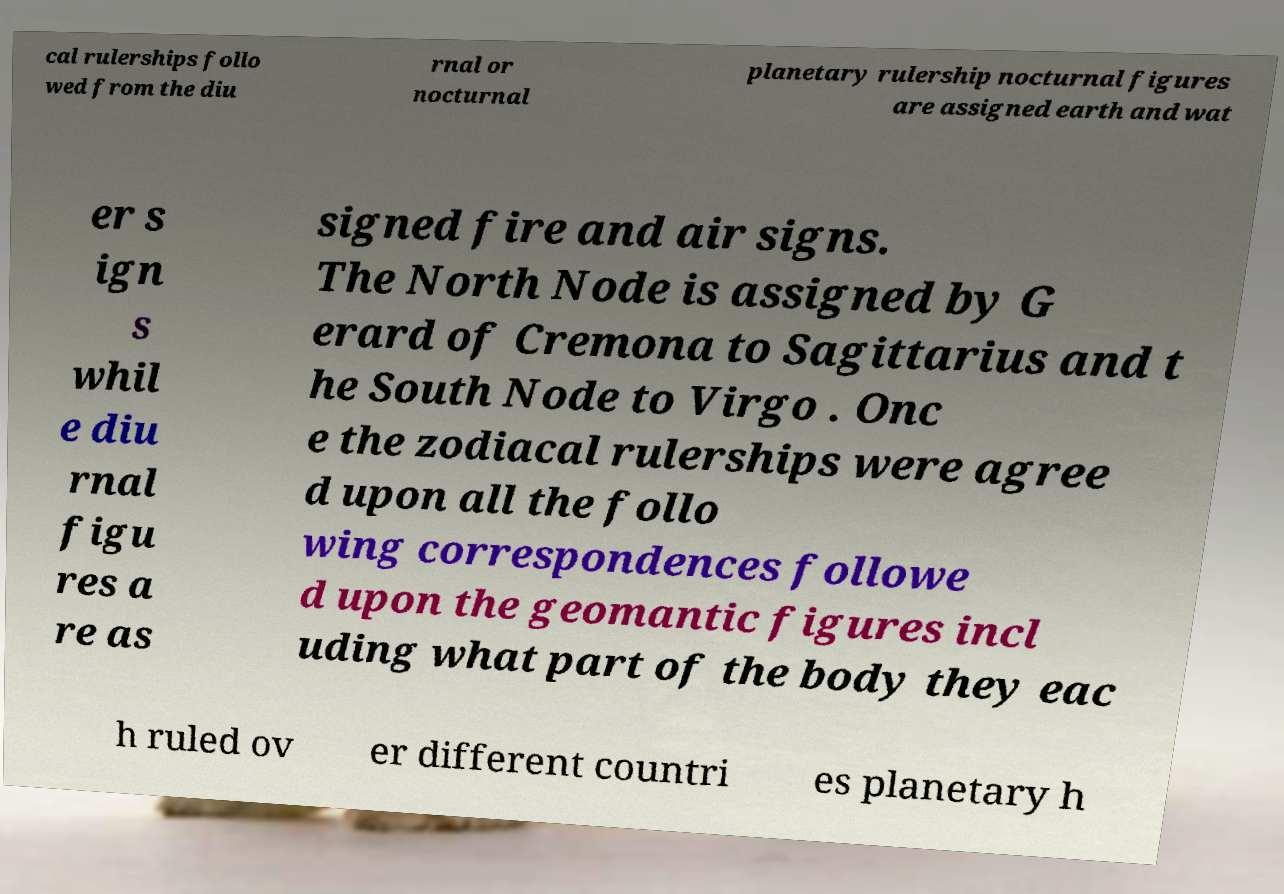Please identify and transcribe the text found in this image. cal rulerships follo wed from the diu rnal or nocturnal planetary rulership nocturnal figures are assigned earth and wat er s ign s whil e diu rnal figu res a re as signed fire and air signs. The North Node is assigned by G erard of Cremona to Sagittarius and t he South Node to Virgo . Onc e the zodiacal rulerships were agree d upon all the follo wing correspondences followe d upon the geomantic figures incl uding what part of the body they eac h ruled ov er different countri es planetary h 